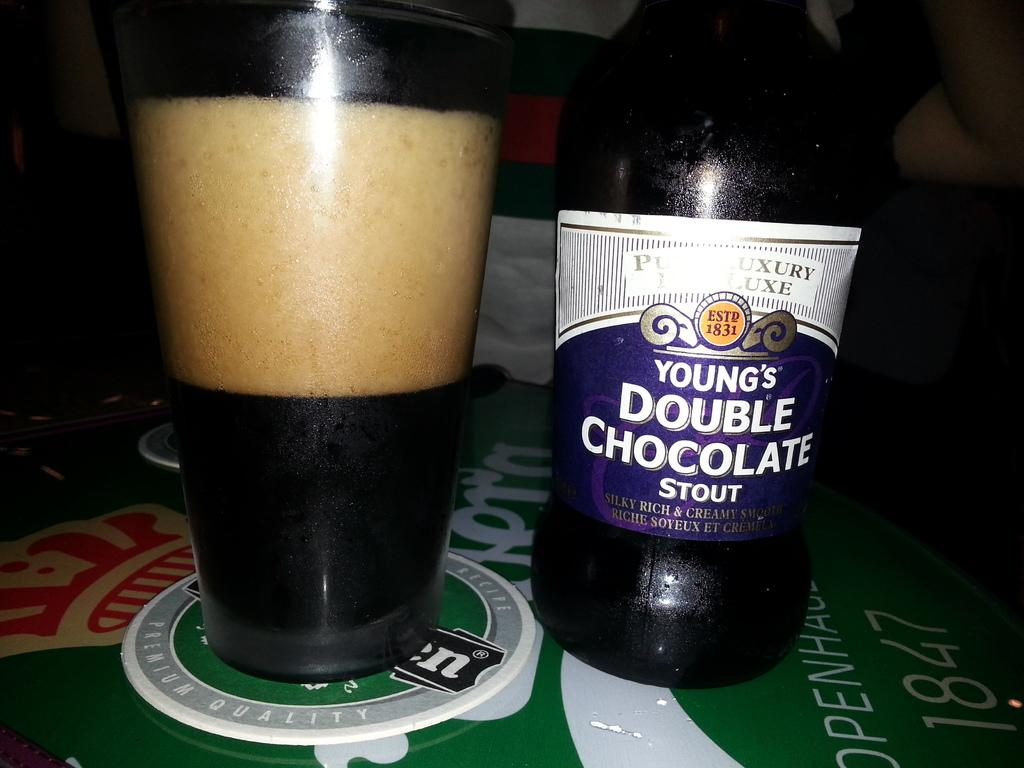<image>
Summarize the visual content of the image. A bottle of Young's Double Chocolate Stout sits next to a glass with a lot of foam in it. 